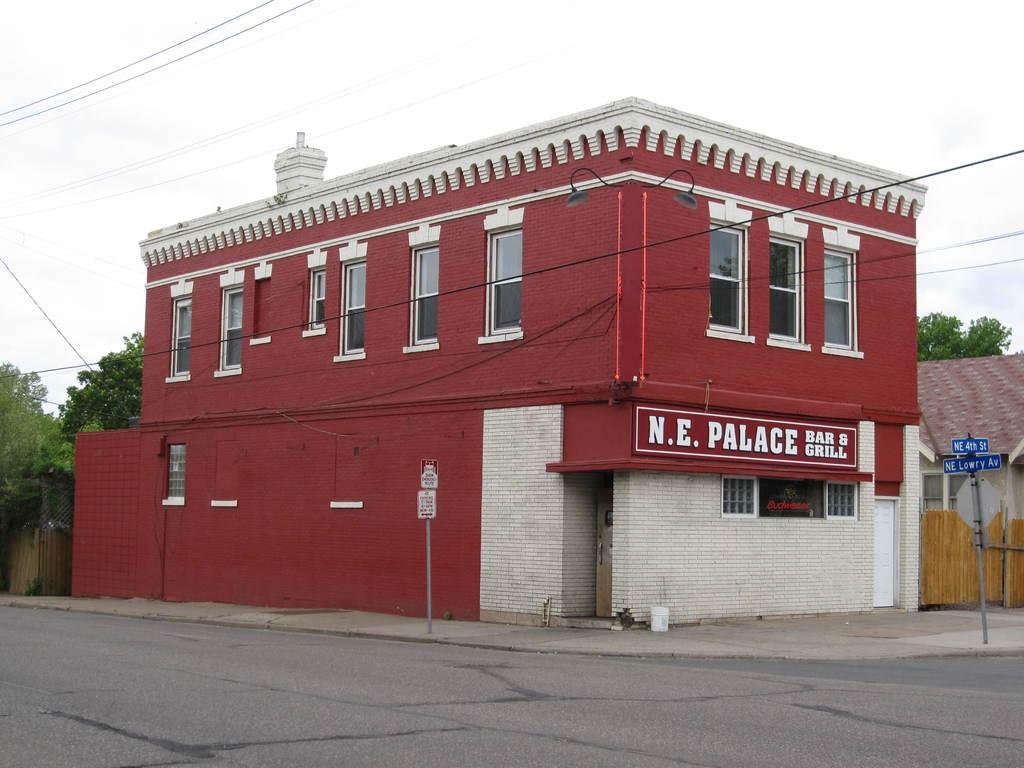What type of structures can be seen in the image? There are buildings in the image. What feature is common to some of the buildings? There are windows in the image. What can be seen illuminating the buildings and streets? There are lights in the image. What type of natural elements are present in the image? There are trees in the image. What type of information might be displayed in the image? There are signboards in the image. What type of bun is being used to hold the attention of the people in the image? There is no bun present in the image, and no indication of people holding attention. What type of apparel is being worn by the trees in the image? Trees do not wear apparel, as they are natural elements and not people. 